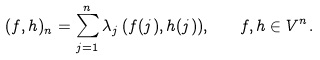<formula> <loc_0><loc_0><loc_500><loc_500>( f , h ) _ { n } = \sum _ { j = 1 } ^ { n } \lambda _ { j } \, ( f ( j ) , h ( j ) ) , \quad f , h \in V ^ { n } .</formula> 